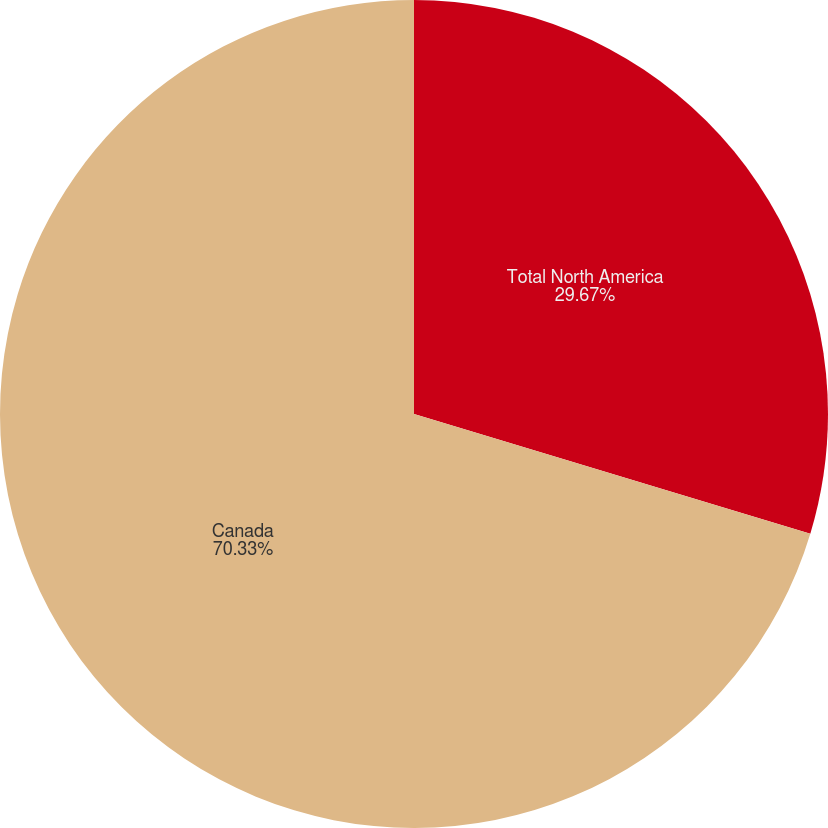Convert chart. <chart><loc_0><loc_0><loc_500><loc_500><pie_chart><fcel>Total North America<fcel>Canada<nl><fcel>29.67%<fcel>70.33%<nl></chart> 